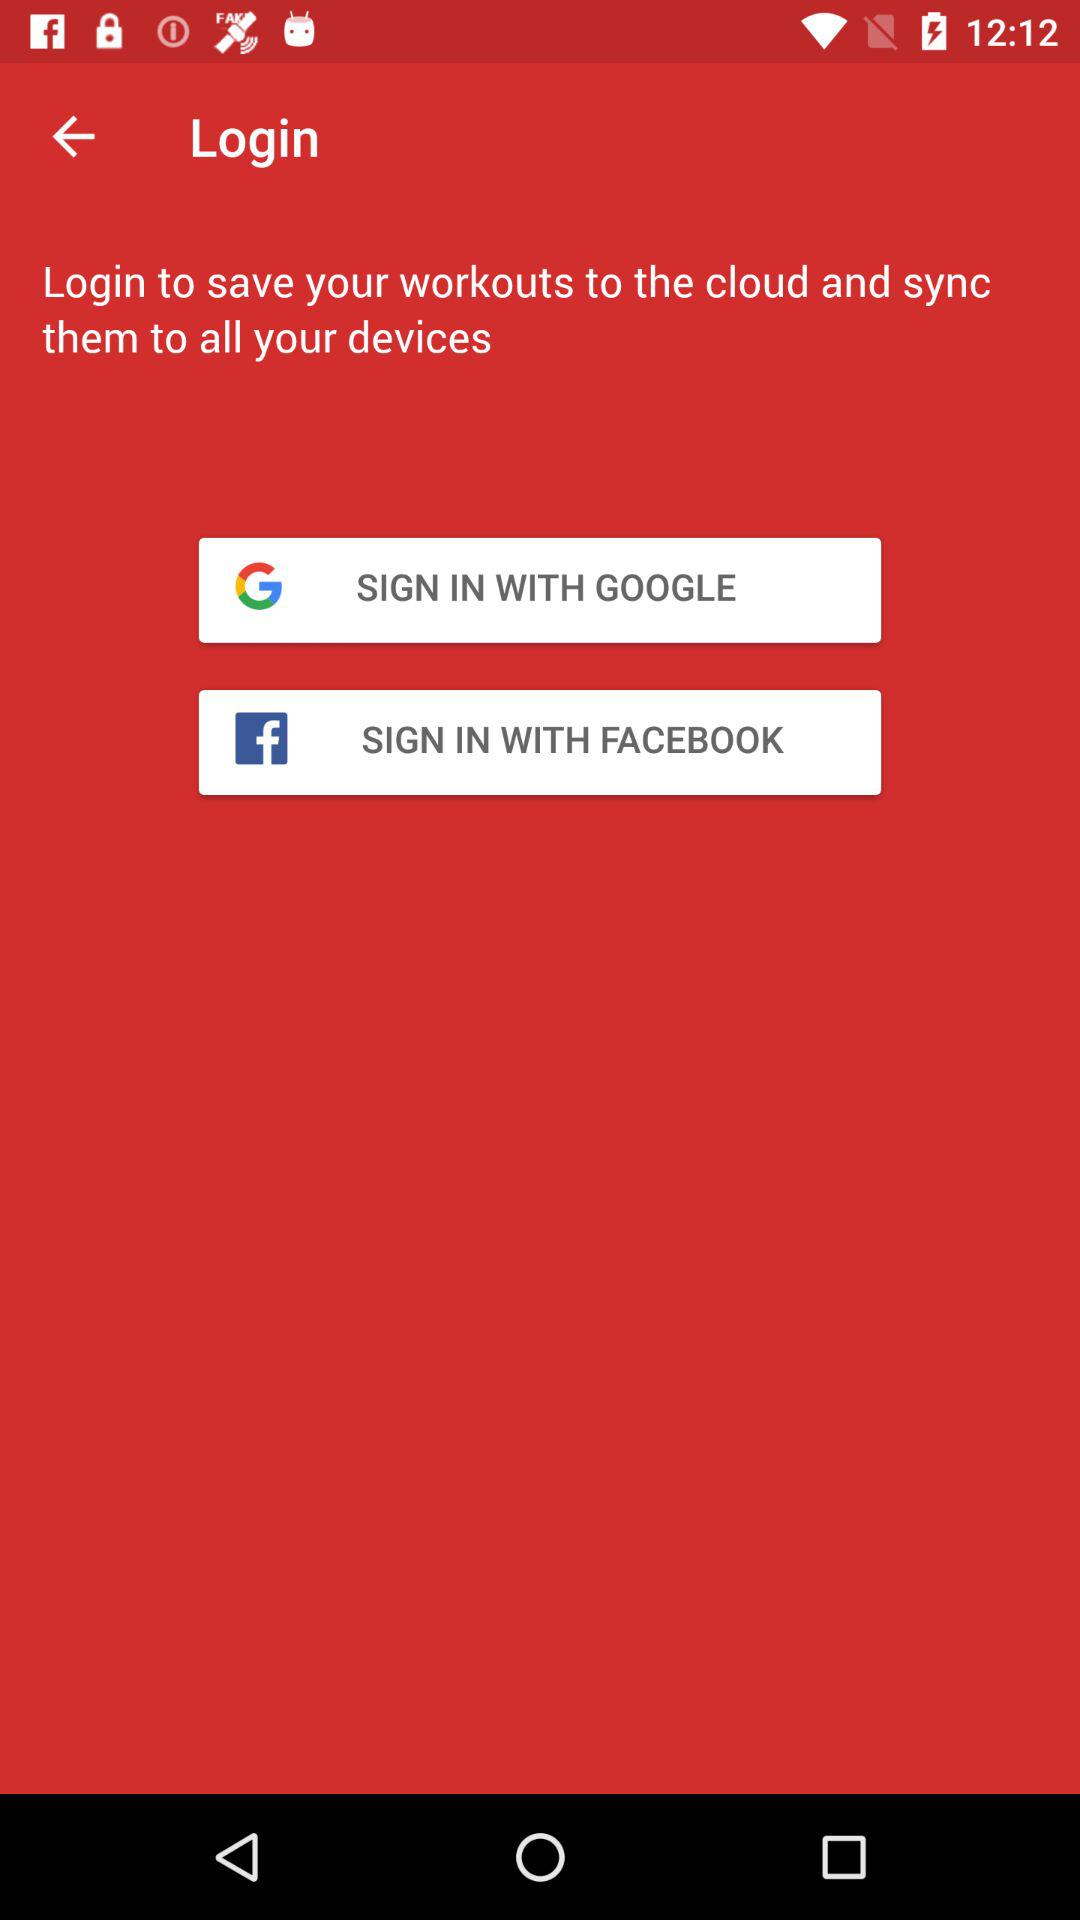What options are available to sign in? The available options are "GOOGLE" and "FACEBOOK". 